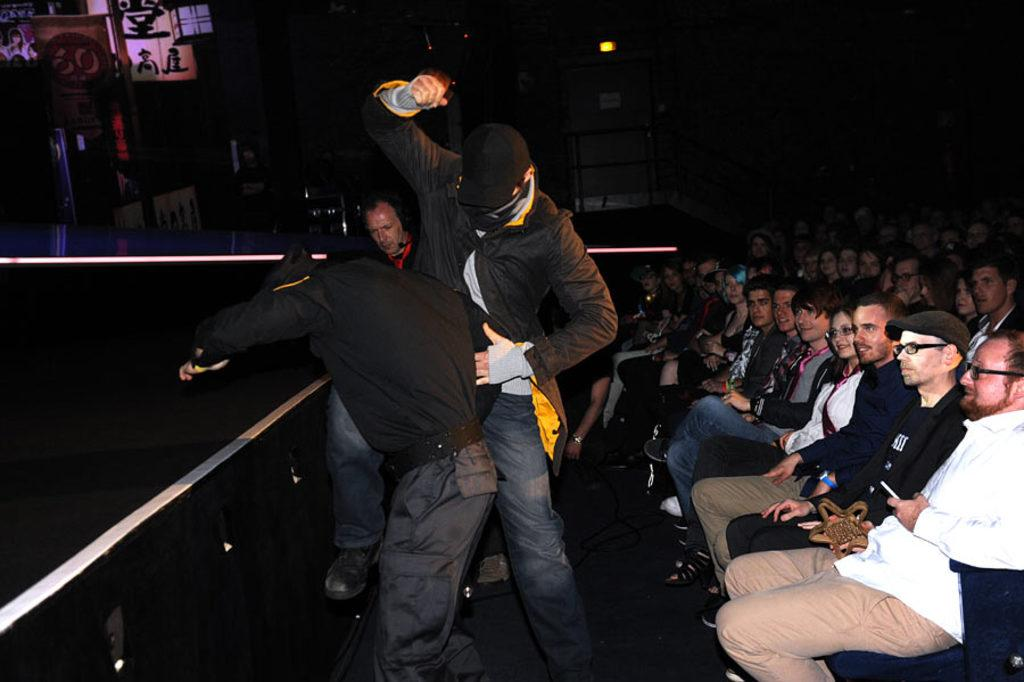What are the people in the image doing? The people in the image are standing in the center. Where is the crowd located in the image? The crowd is sitting on the right side of the image. What can be seen in the background of the image? There is a wall and boards visible in the background. How much self-awareness does the wall in the image possess? The wall in the image does not possess self-awareness, as it is an inanimate object. 